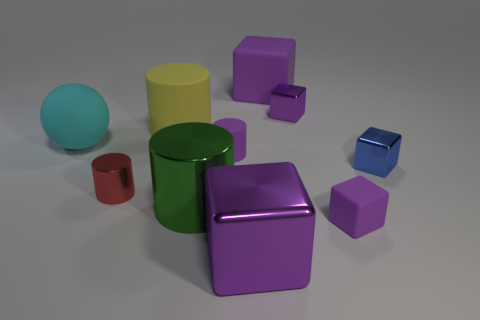Subtract all purple blocks. How many were subtracted if there are1purple blocks left? 3 Subtract all cyan balls. How many purple blocks are left? 4 Subtract all green cylinders. Subtract all blue balls. How many cylinders are left? 3 Subtract all balls. How many objects are left? 9 Subtract all big yellow spheres. Subtract all purple cylinders. How many objects are left? 9 Add 4 blue cubes. How many blue cubes are left? 5 Add 7 big green objects. How many big green objects exist? 8 Subtract 1 yellow cylinders. How many objects are left? 9 